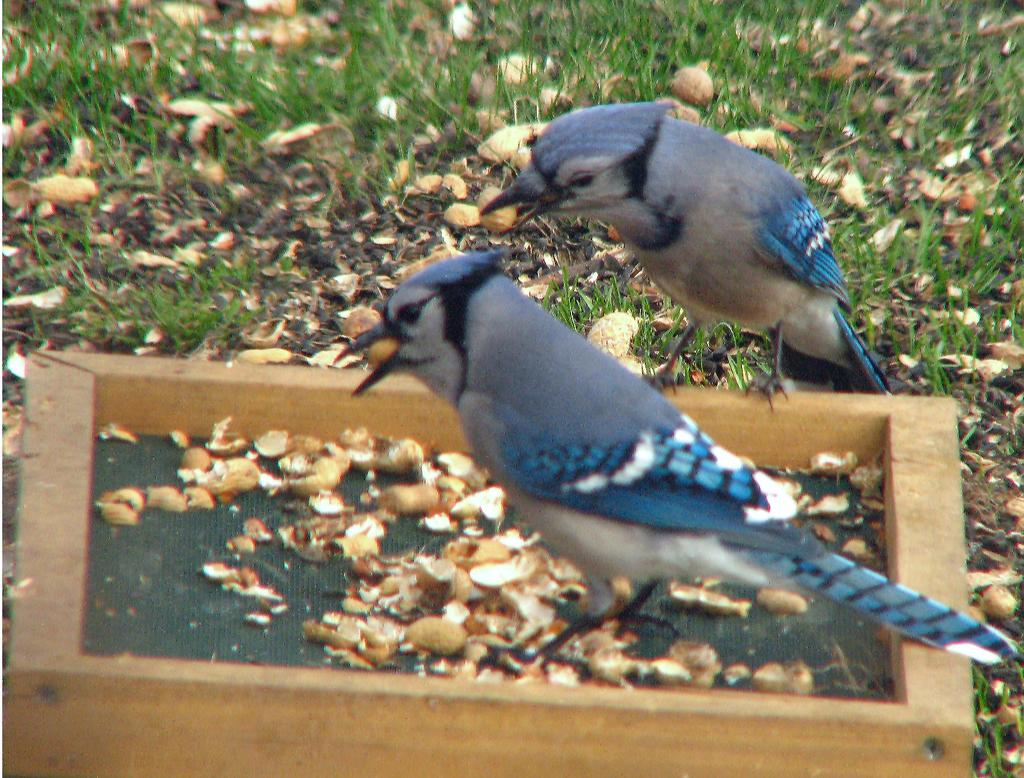How many birds can be seen in the image? There are two birds in the image. What are the birds standing on? The birds are standing on a wooden object. What can be found inside the wooden object? There are peanut shells in the wooden object. What type of natural environment is visible in the image? There is grass visible in the image. What color is the bird's eye in the image? The provided facts do not mention the color of the bird's eye, and there is no information about the eye in the image. 